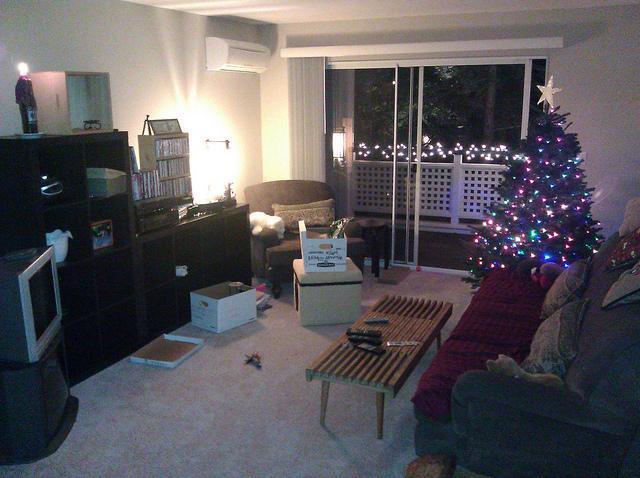How many lamps are in the picture?
Give a very brief answer. 2. How many horses are eating grass?
Give a very brief answer. 0. 